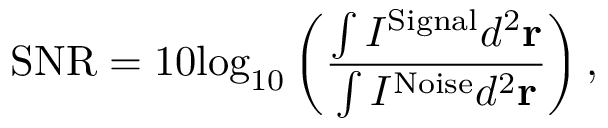Convert formula to latex. <formula><loc_0><loc_0><loc_500><loc_500>S N R = 1 0 { { \log } _ { 1 0 } } \left ( \frac { \int { { { I } ^ { S i g n a l } } } { { d } ^ { 2 } } { r } } { \int { { { I } ^ { N o i s e } } } { { d } ^ { 2 } } { r } } \right ) ,</formula> 